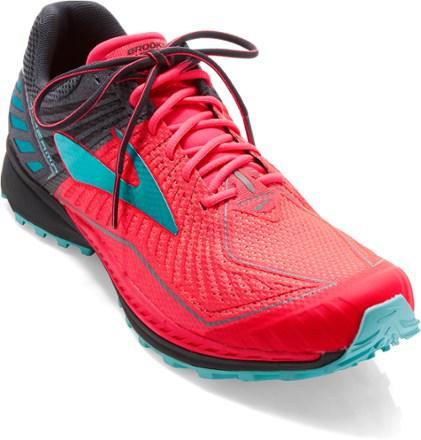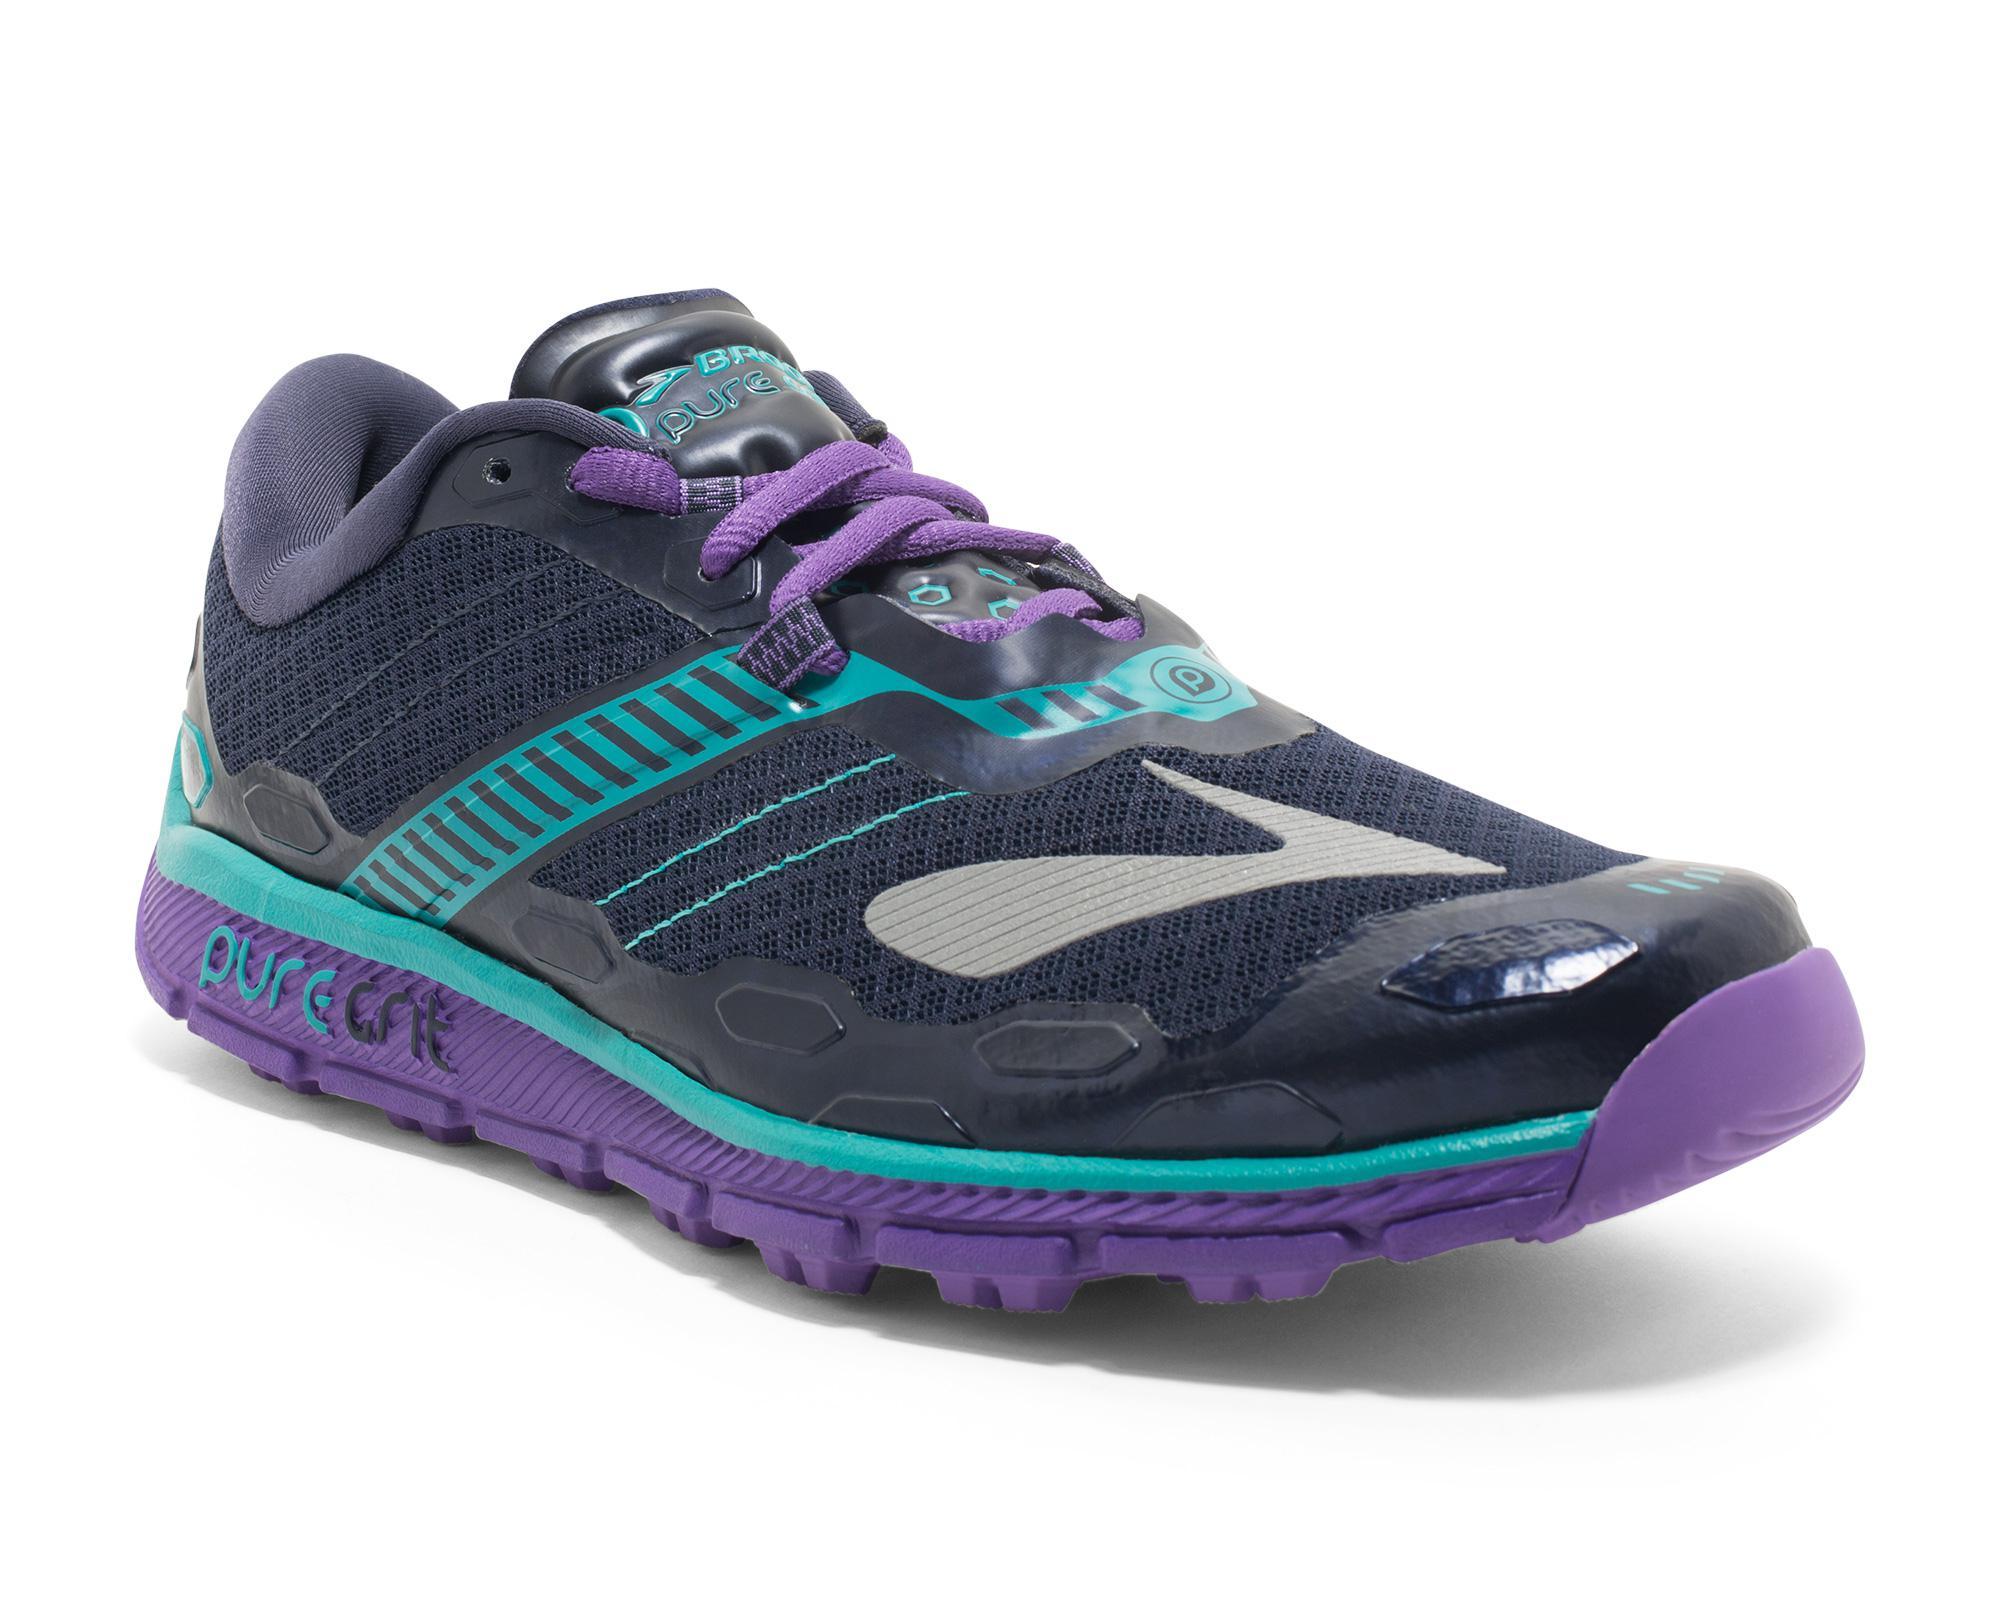The first image is the image on the left, the second image is the image on the right. Evaluate the accuracy of this statement regarding the images: "One of the shoes has the laces tied in a bow.". Is it true? Answer yes or no. Yes. The first image is the image on the left, the second image is the image on the right. Given the left and right images, does the statement "The shoe on the left has laces tied into a bow while the shoe on the right has laces that tighten without tying." hold true? Answer yes or no. Yes. 